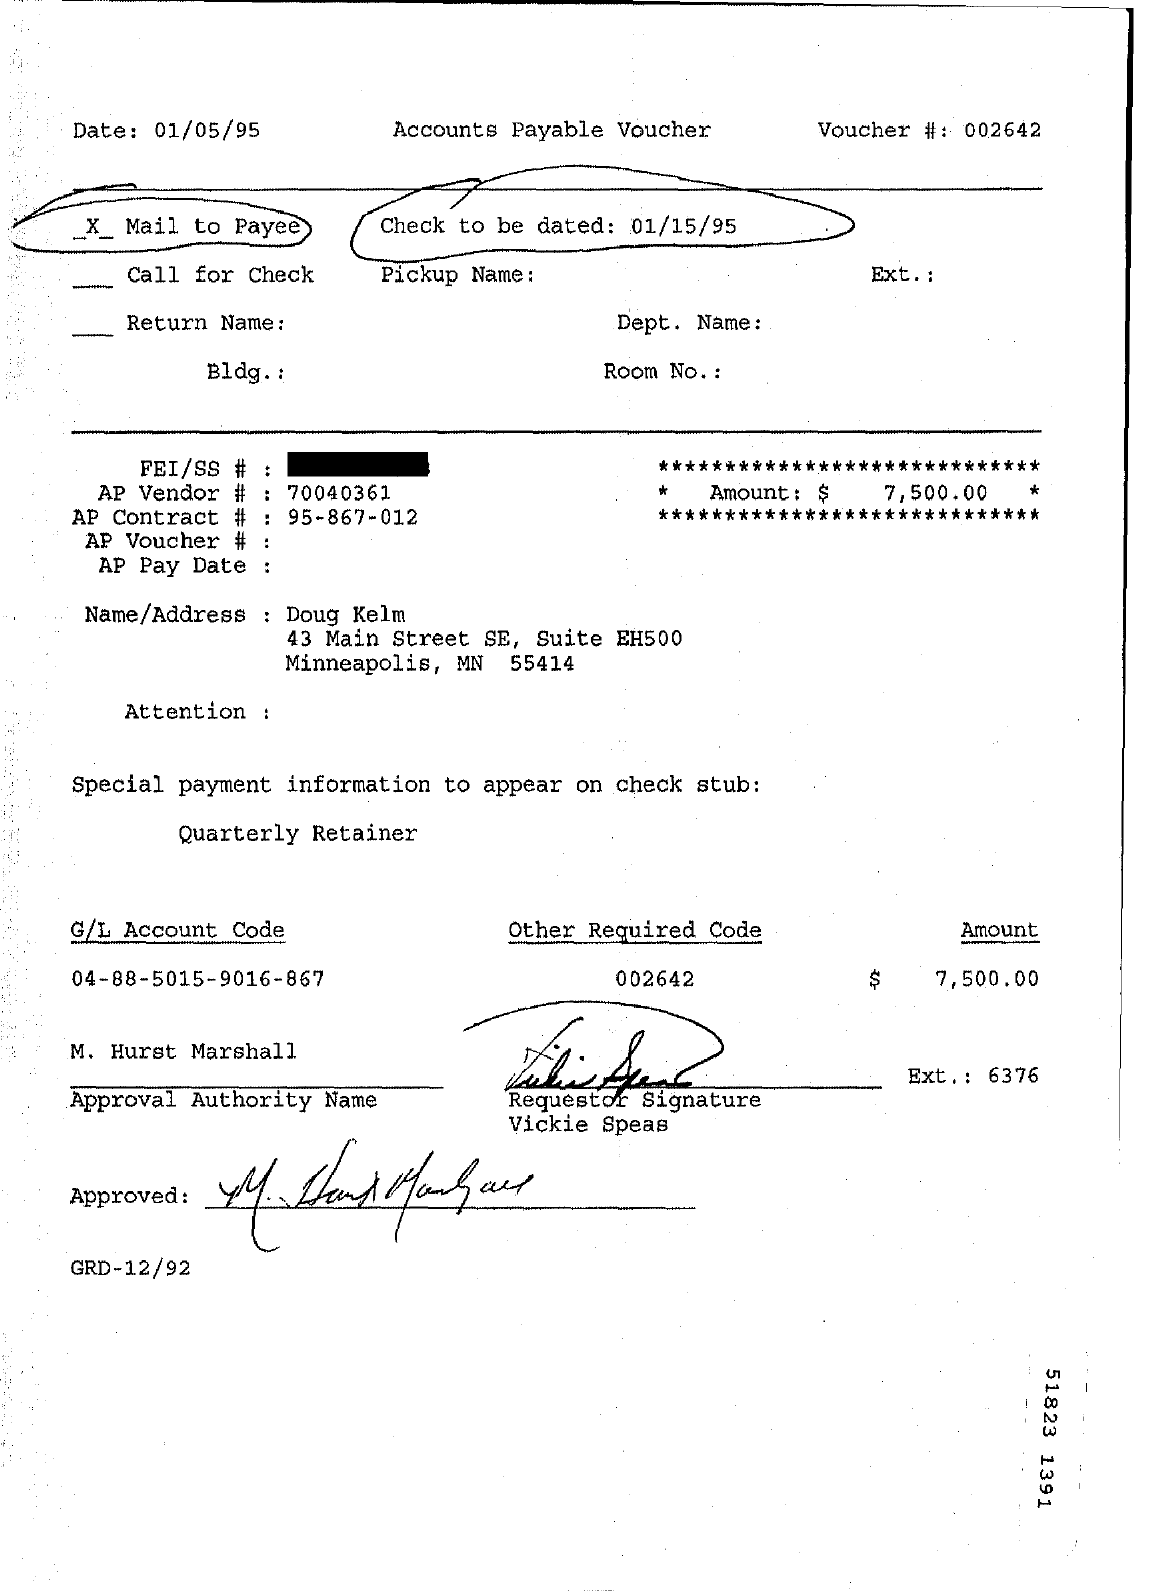What is the Date mentioned in the top left of the document ?
Your answer should be very brief. 01/05/95. What type of this Document ?
Provide a succinct answer. Accounts Payable Voucher. What is the Voucher Number ?
Your response must be concise. 002642. What is the AP Vendor Number ?
Give a very brief answer. 70040361. What is the AP Contract Number ?
Provide a short and direct response. 95-867-012. What is the other Required Code Number ?
Ensure brevity in your answer.  002642. What is the G/L Account Code ?
Give a very brief answer. 04-88-5015-9016-867. How much Amount ?
Make the answer very short. 7,500.00. 